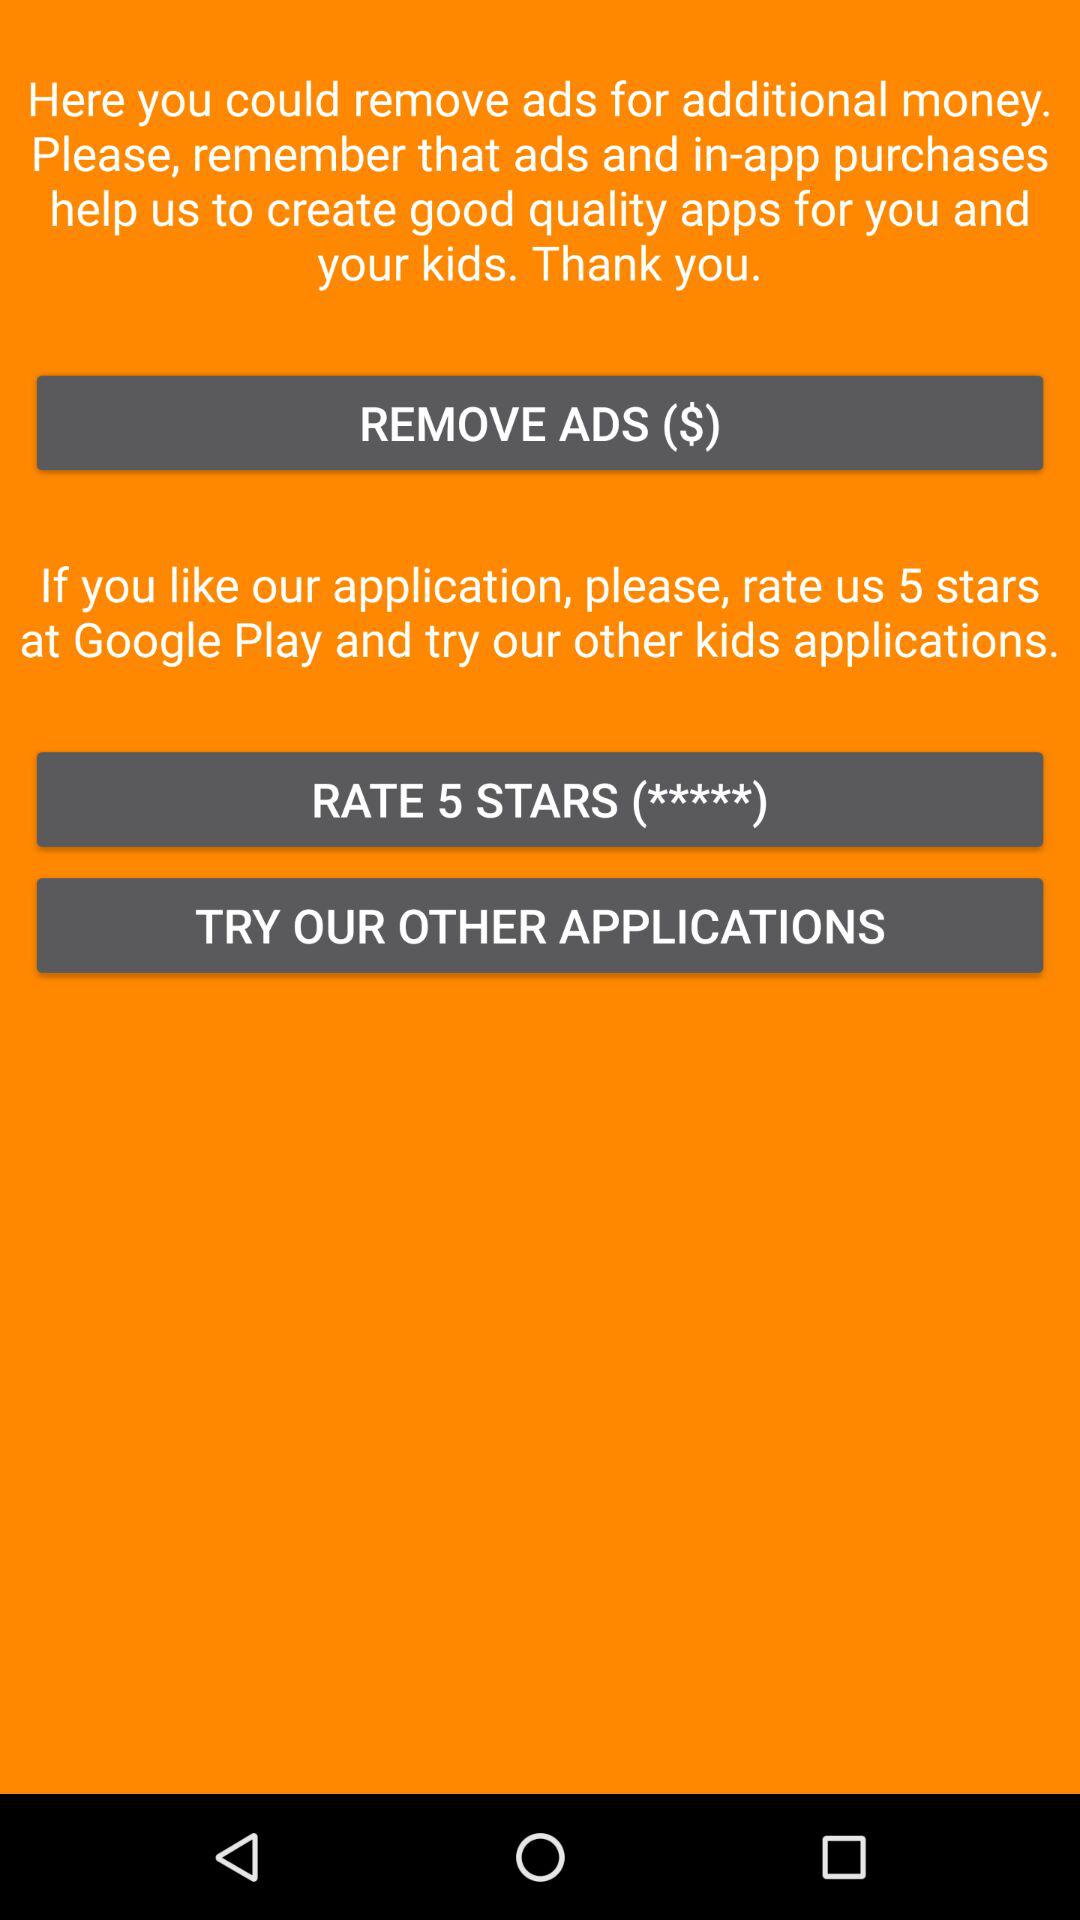Why are ads removed?
When the provided information is insufficient, respond with <no answer>. <no answer> 